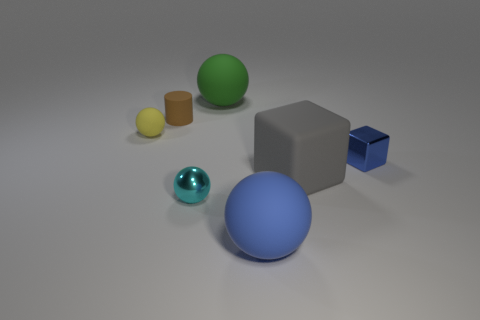Subtract all large green rubber spheres. How many spheres are left? 3 Add 1 small yellow things. How many objects exist? 8 Subtract 3 balls. How many balls are left? 1 Subtract all blue cubes. How many cubes are left? 1 Subtract all cubes. How many objects are left? 5 Add 4 small cyan objects. How many small cyan objects are left? 5 Add 6 big green objects. How many big green objects exist? 7 Subtract 0 blue cylinders. How many objects are left? 7 Subtract all blue cubes. Subtract all red cylinders. How many cubes are left? 1 Subtract all blue objects. Subtract all big green matte things. How many objects are left? 4 